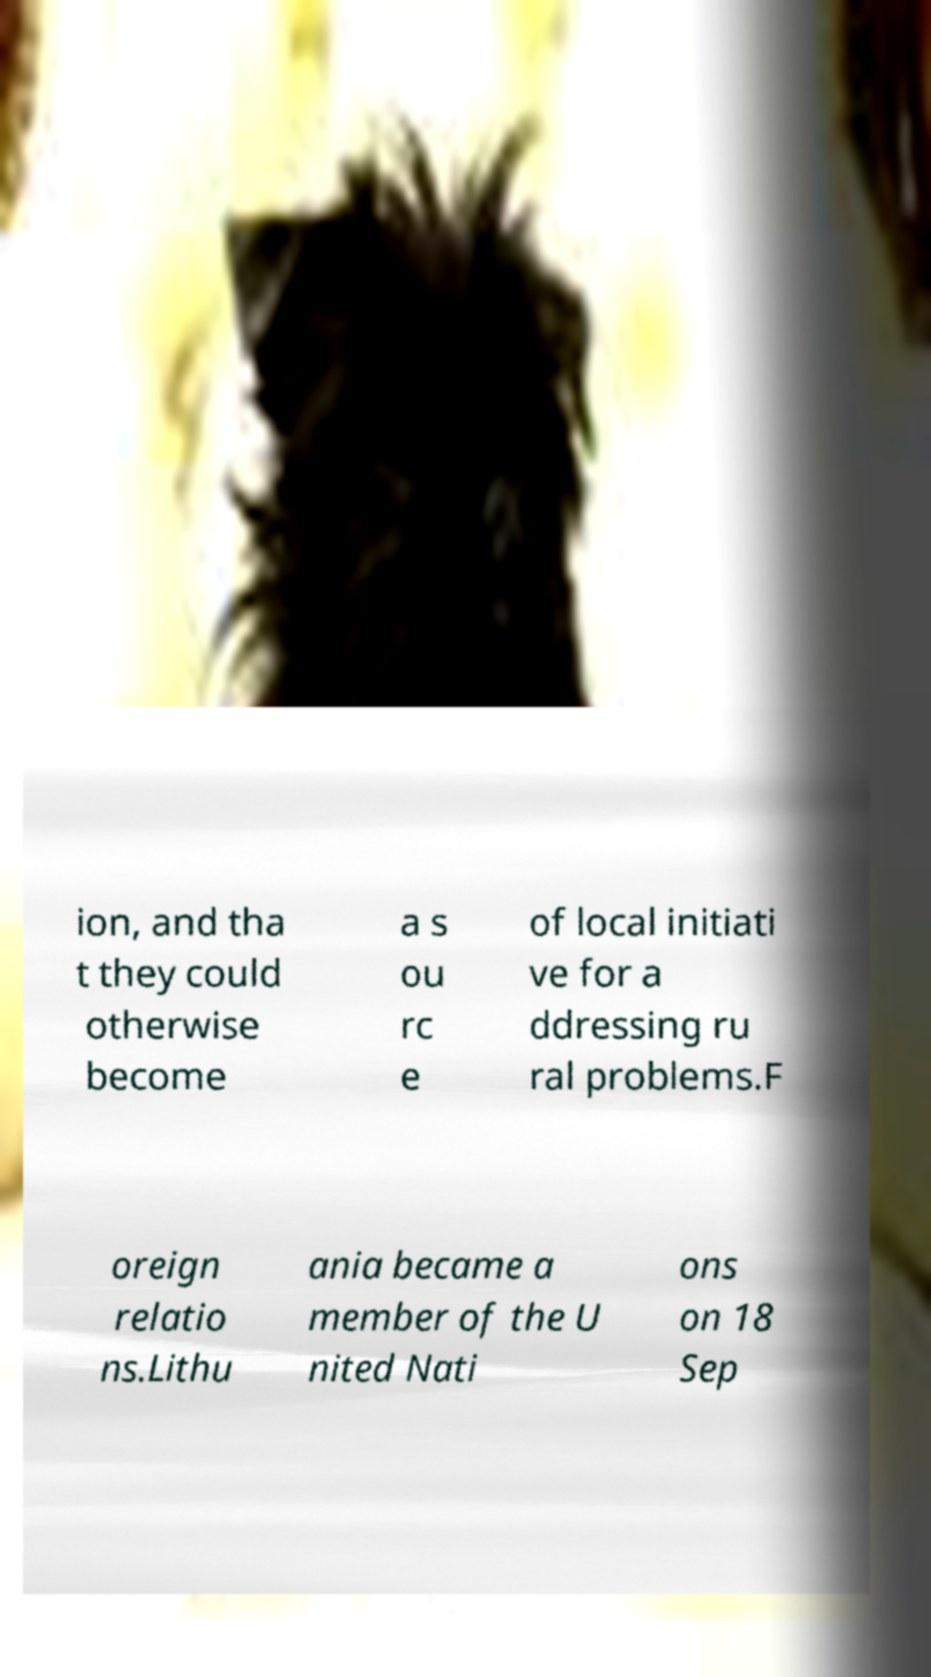Could you assist in decoding the text presented in this image and type it out clearly? ion, and tha t they could otherwise become a s ou rc e of local initiati ve for a ddressing ru ral problems.F oreign relatio ns.Lithu ania became a member of the U nited Nati ons on 18 Sep 